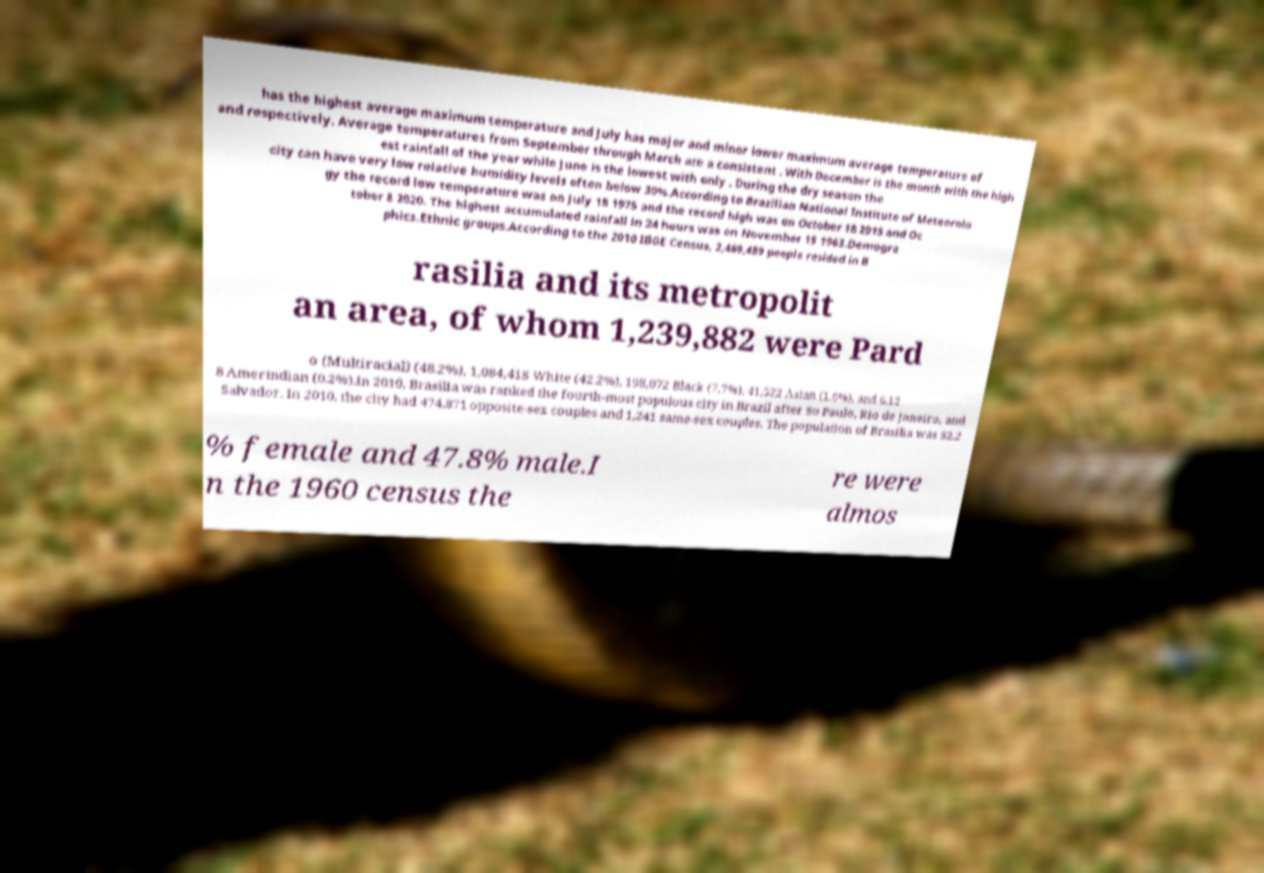Can you accurately transcribe the text from the provided image for me? has the highest average maximum temperature and July has major and minor lower maximum average temperature of and respectively. Average temperatures from September through March are a consistent . With December is the month with the high est rainfall of the year while June is the lowest with only . During the dry season the city can have very low relative humidity levels often below 30%.According to Brazilian National Institute of Meteorolo gy the record low temperature was on July 18 1975 and the record high was on October 18 2015 and Oc tober 8 2020. The highest accumulated rainfall in 24 hours was on November 15 1963.Demogra phics.Ethnic groups.According to the 2010 IBGE Census, 2,469,489 people resided in B rasilia and its metropolit an area, of whom 1,239,882 were Pard o (Multiracial) (48.2%), 1,084,418 White (42.2%), 198,072 Black (7.7%), 41,522 Asian (1.6%), and 6,12 8 Amerindian (0.2%).In 2010, Brasilia was ranked the fourth-most populous city in Brazil after So Paulo, Rio de Janeiro, and Salvador. In 2010, the city had 474,871 opposite-sex couples and 1,241 same-sex couples. The population of Brasilia was 52.2 % female and 47.8% male.I n the 1960 census the re were almos 